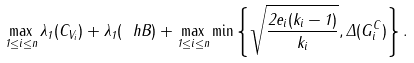Convert formula to latex. <formula><loc_0><loc_0><loc_500><loc_500>\max _ { 1 \leq i \leq n } \lambda _ { 1 } ( C _ { V _ { i } } ) + \lambda _ { 1 } ( \ h B ) + \max _ { 1 \leq i \leq n } \min \left \{ \sqrt { \frac { 2 e _ { i } ( k _ { i } - 1 ) } { k _ { i } } } , \Delta ( G _ { i } ^ { C } ) \right \} .</formula> 